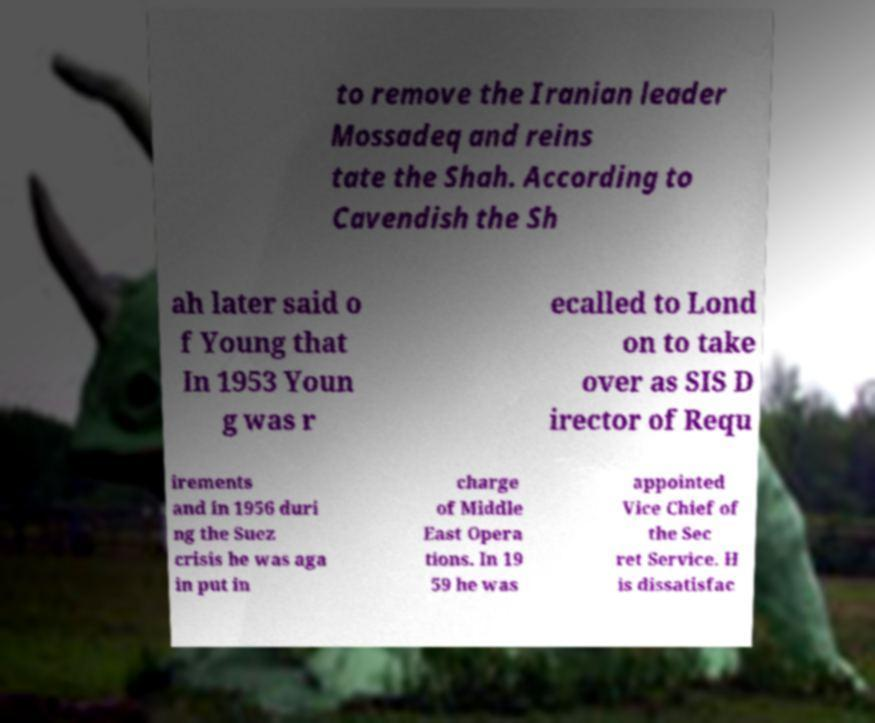Can you accurately transcribe the text from the provided image for me? to remove the Iranian leader Mossadeq and reins tate the Shah. According to Cavendish the Sh ah later said o f Young that In 1953 Youn g was r ecalled to Lond on to take over as SIS D irector of Requ irements and in 1956 duri ng the Suez crisis he was aga in put in charge of Middle East Opera tions. In 19 59 he was appointed Vice Chief of the Sec ret Service. H is dissatisfac 